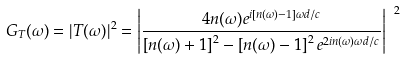<formula> <loc_0><loc_0><loc_500><loc_500>G _ { T } ( \omega ) = | T ( \omega ) | ^ { 2 } = \left | \frac { 4 n ( \omega ) e ^ { i \left [ n ( \omega ) - 1 \right ] \omega d / c } } { \left [ n ( \omega ) + 1 \right ] ^ { 2 } - \left [ n ( \omega ) - 1 \right ] ^ { 2 } e ^ { 2 i n ( \omega ) \omega d / c } } \right | ^ { \ 2 }</formula> 